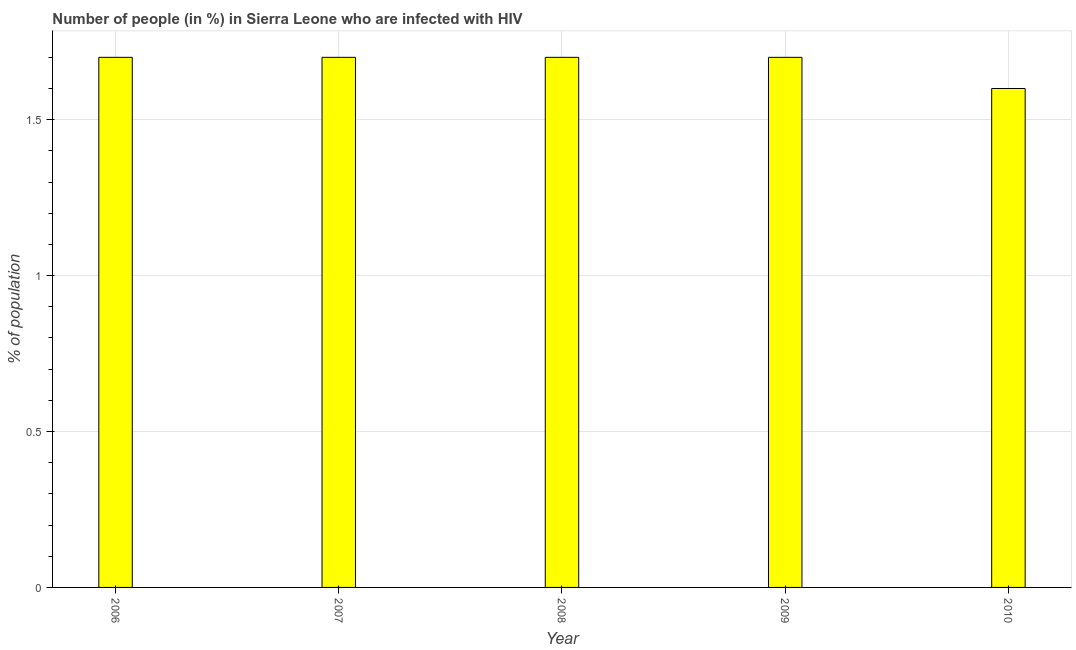Does the graph contain any zero values?
Give a very brief answer. No. What is the title of the graph?
Your response must be concise. Number of people (in %) in Sierra Leone who are infected with HIV. What is the label or title of the Y-axis?
Give a very brief answer. % of population. What is the number of people infected with hiv in 2008?
Make the answer very short. 1.7. Across all years, what is the maximum number of people infected with hiv?
Make the answer very short. 1.7. Across all years, what is the minimum number of people infected with hiv?
Provide a short and direct response. 1.6. In which year was the number of people infected with hiv maximum?
Make the answer very short. 2006. What is the sum of the number of people infected with hiv?
Provide a short and direct response. 8.4. What is the difference between the number of people infected with hiv in 2009 and 2010?
Provide a succinct answer. 0.1. What is the average number of people infected with hiv per year?
Ensure brevity in your answer.  1.68. What is the median number of people infected with hiv?
Provide a succinct answer. 1.7. What is the ratio of the number of people infected with hiv in 2007 to that in 2008?
Keep it short and to the point. 1. What is the difference between the highest and the second highest number of people infected with hiv?
Offer a very short reply. 0. Is the sum of the number of people infected with hiv in 2008 and 2010 greater than the maximum number of people infected with hiv across all years?
Give a very brief answer. Yes. What is the difference between the highest and the lowest number of people infected with hiv?
Provide a succinct answer. 0.1. How many bars are there?
Offer a very short reply. 5. How many years are there in the graph?
Make the answer very short. 5. What is the % of population of 2008?
Make the answer very short. 1.7. What is the % of population in 2009?
Your answer should be compact. 1.7. What is the % of population of 2010?
Keep it short and to the point. 1.6. What is the difference between the % of population in 2006 and 2009?
Provide a succinct answer. 0. What is the difference between the % of population in 2007 and 2008?
Your answer should be compact. 0. What is the difference between the % of population in 2007 and 2009?
Offer a terse response. 0. What is the difference between the % of population in 2007 and 2010?
Keep it short and to the point. 0.1. What is the difference between the % of population in 2009 and 2010?
Make the answer very short. 0.1. What is the ratio of the % of population in 2006 to that in 2007?
Provide a succinct answer. 1. What is the ratio of the % of population in 2006 to that in 2010?
Your response must be concise. 1.06. What is the ratio of the % of population in 2007 to that in 2010?
Your response must be concise. 1.06. What is the ratio of the % of population in 2008 to that in 2010?
Your answer should be compact. 1.06. What is the ratio of the % of population in 2009 to that in 2010?
Offer a terse response. 1.06. 